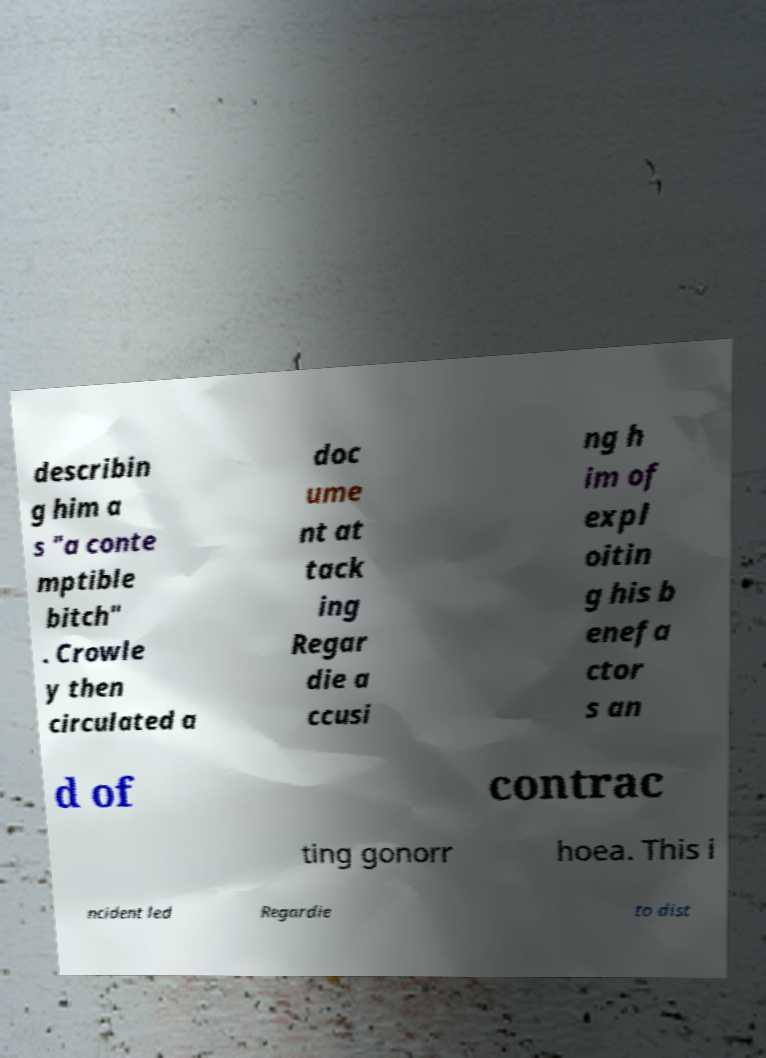Could you extract and type out the text from this image? describin g him a s "a conte mptible bitch" . Crowle y then circulated a doc ume nt at tack ing Regar die a ccusi ng h im of expl oitin g his b enefa ctor s an d of contrac ting gonorr hoea. This i ncident led Regardie to dist 